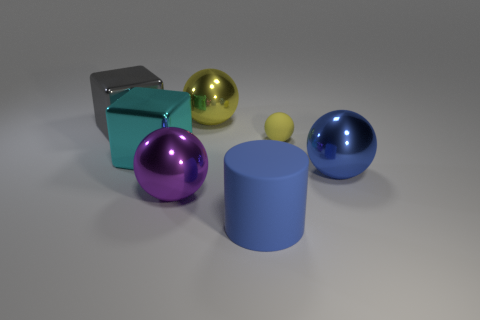Subtract all big balls. How many balls are left? 1 Add 2 small gray rubber objects. How many objects exist? 9 Subtract 1 cubes. How many cubes are left? 1 Subtract all yellow spheres. How many spheres are left? 2 Subtract all balls. How many objects are left? 3 Subtract all cyan cylinders. How many gray cubes are left? 1 Add 5 big shiny objects. How many big shiny objects exist? 10 Subtract 0 purple cubes. How many objects are left? 7 Subtract all green spheres. Subtract all red cylinders. How many spheres are left? 4 Subtract all cyan metal blocks. Subtract all green objects. How many objects are left? 6 